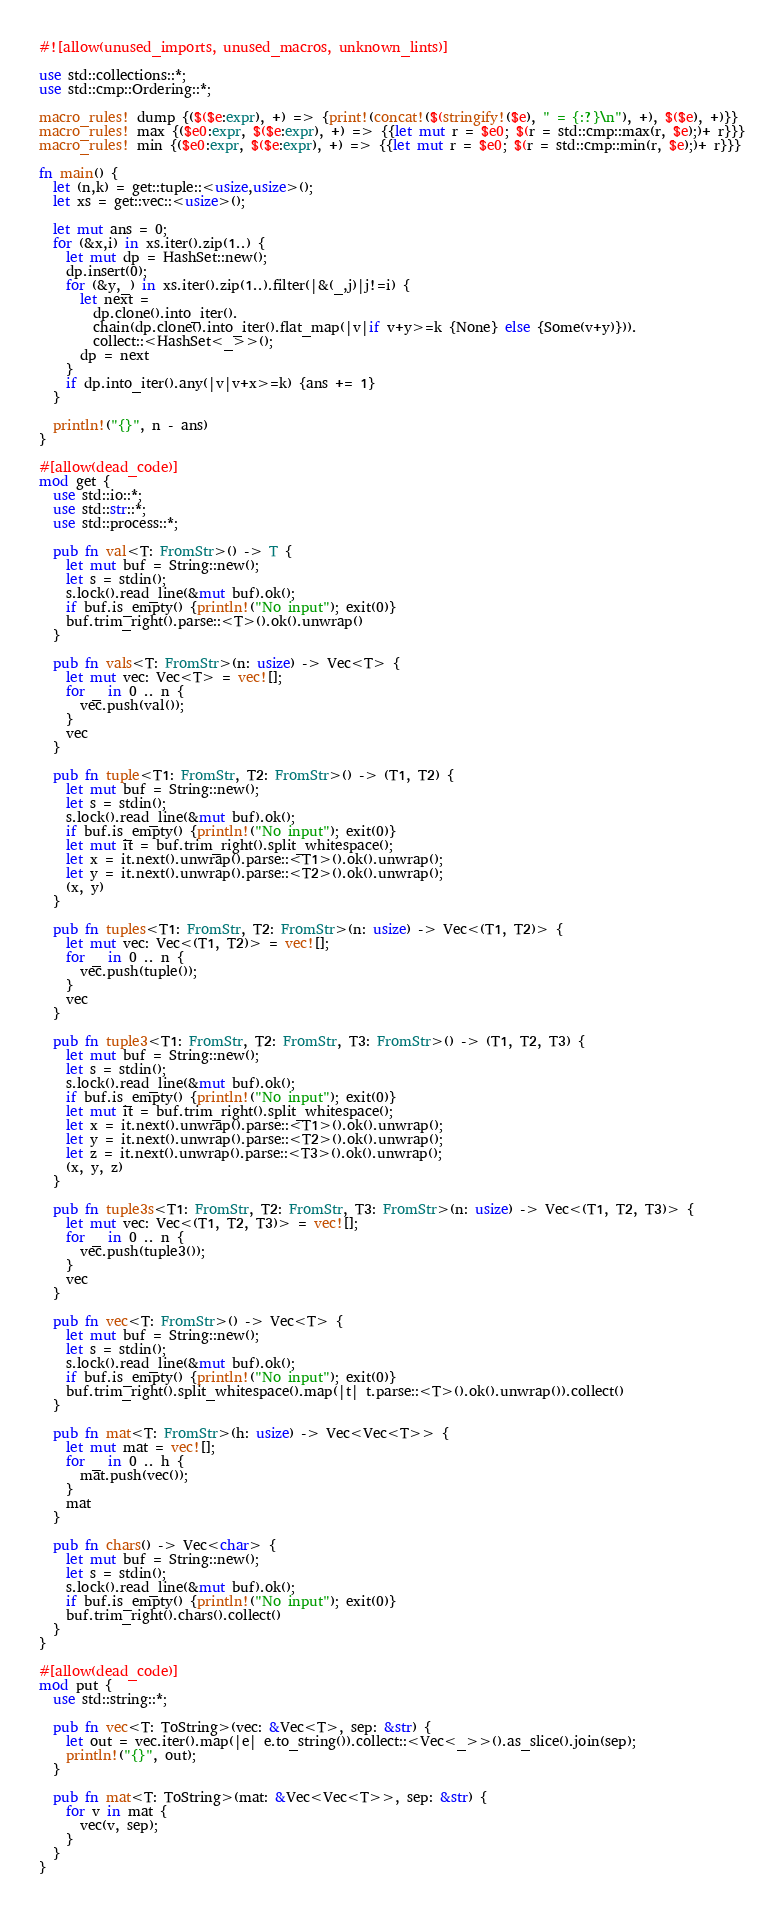<code> <loc_0><loc_0><loc_500><loc_500><_Rust_>#![allow(unused_imports, unused_macros, unknown_lints)]

use std::collections::*;
use std::cmp::Ordering::*;

macro_rules! dump {($($e:expr), +) => {print!(concat!($(stringify!($e), " = {:?}\n"), +), $($e), +)}}
macro_rules! max {($e0:expr, $($e:expr), +) => {{let mut r = $e0; $(r = std::cmp::max(r, $e);)+ r}}}
macro_rules! min {($e0:expr, $($e:expr), +) => {{let mut r = $e0; $(r = std::cmp::min(r, $e);)+ r}}}

fn main() {
  let (n,k) = get::tuple::<usize,usize>();
  let xs = get::vec::<usize>();
  
  let mut ans = 0;
  for (&x,i) in xs.iter().zip(1..) {
    let mut dp = HashSet::new();
    dp.insert(0);
    for (&y,_) in xs.iter().zip(1..).filter(|&(_,j)|j!=i) {
      let next =
        dp.clone().into_iter().
        chain(dp.clone().into_iter().flat_map(|v|if v+y>=k {None} else {Some(v+y)})).
        collect::<HashSet<_>>();
      dp = next
    }
    if dp.into_iter().any(|v|v+x>=k) {ans += 1}
  }
   
  println!("{}", n - ans)
}

#[allow(dead_code)]
mod get {
  use std::io::*;
  use std::str::*;
  use std::process::*;

  pub fn val<T: FromStr>() -> T {
    let mut buf = String::new();
    let s = stdin();
    s.lock().read_line(&mut buf).ok();
    if buf.is_empty() {println!("No input"); exit(0)}
    buf.trim_right().parse::<T>().ok().unwrap()
  }

  pub fn vals<T: FromStr>(n: usize) -> Vec<T> {
    let mut vec: Vec<T> = vec![];
    for _ in 0 .. n {
      vec.push(val());
    }
    vec
  }

  pub fn tuple<T1: FromStr, T2: FromStr>() -> (T1, T2) {
    let mut buf = String::new();
    let s = stdin();
    s.lock().read_line(&mut buf).ok();
    if buf.is_empty() {println!("No input"); exit(0)}
    let mut it = buf.trim_right().split_whitespace();
    let x = it.next().unwrap().parse::<T1>().ok().unwrap();
    let y = it.next().unwrap().parse::<T2>().ok().unwrap();
    (x, y)
  }

  pub fn tuples<T1: FromStr, T2: FromStr>(n: usize) -> Vec<(T1, T2)> {
    let mut vec: Vec<(T1, T2)> = vec![];
    for _ in 0 .. n {
      vec.push(tuple());
    }
    vec
  }

  pub fn tuple3<T1: FromStr, T2: FromStr, T3: FromStr>() -> (T1, T2, T3) {
    let mut buf = String::new();
    let s = stdin();
    s.lock().read_line(&mut buf).ok();
    if buf.is_empty() {println!("No input"); exit(0)}
    let mut it = buf.trim_right().split_whitespace();
    let x = it.next().unwrap().parse::<T1>().ok().unwrap();
    let y = it.next().unwrap().parse::<T2>().ok().unwrap();
    let z = it.next().unwrap().parse::<T3>().ok().unwrap();
    (x, y, z)
  }

  pub fn tuple3s<T1: FromStr, T2: FromStr, T3: FromStr>(n: usize) -> Vec<(T1, T2, T3)> {
    let mut vec: Vec<(T1, T2, T3)> = vec![];
    for _ in 0 .. n {
      vec.push(tuple3());
    }
    vec
  }

  pub fn vec<T: FromStr>() -> Vec<T> {
    let mut buf = String::new();
    let s = stdin();
    s.lock().read_line(&mut buf).ok();
    if buf.is_empty() {println!("No input"); exit(0)}
    buf.trim_right().split_whitespace().map(|t| t.parse::<T>().ok().unwrap()).collect()
  }

  pub fn mat<T: FromStr>(h: usize) -> Vec<Vec<T>> {
    let mut mat = vec![];
    for _ in 0 .. h {
      mat.push(vec());
    }
    mat
  }

  pub fn chars() -> Vec<char> {
    let mut buf = String::new();
    let s = stdin();
    s.lock().read_line(&mut buf).ok();
    if buf.is_empty() {println!("No input"); exit(0)}
    buf.trim_right().chars().collect()
  }
}

#[allow(dead_code)]
mod put {
  use std::string::*;

  pub fn vec<T: ToString>(vec: &Vec<T>, sep: &str) {
    let out = vec.iter().map(|e| e.to_string()).collect::<Vec<_>>().as_slice().join(sep);
    println!("{}", out);
  }

  pub fn mat<T: ToString>(mat: &Vec<Vec<T>>, sep: &str) {
    for v in mat {
      vec(v, sep);
    }
  }
}
</code> 